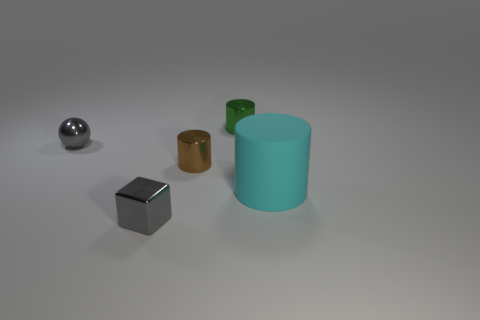If you had to relate these objects to a concept or a field, what would it be? These objects could relate to the concept of comparative geometry in the field of mathematics or design, where the focus is on analyzing and understanding different geometric forms, their proportions, and their spatial relationships. 